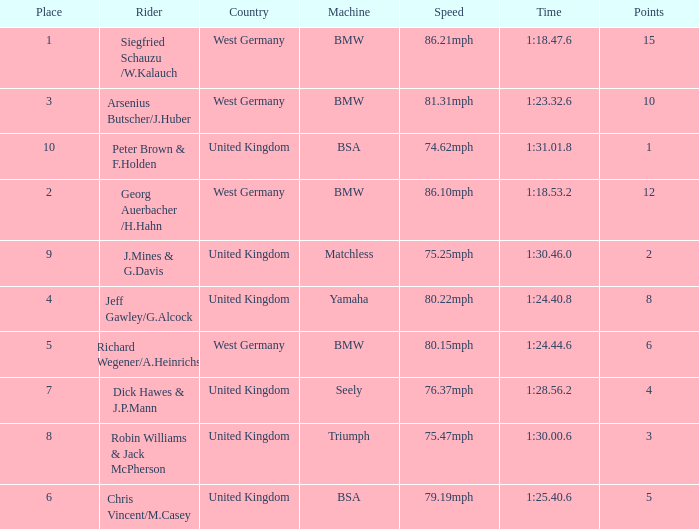Which place has points larger than 1, a bmw machine, and a time of 1:18.47.6? 1.0. 